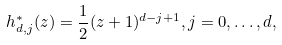<formula> <loc_0><loc_0><loc_500><loc_500>h _ { d , j } ^ { * } ( z ) = \frac { 1 } { 2 } ( z + 1 ) ^ { d - j + 1 } , j = 0 , \dots , d ,</formula> 